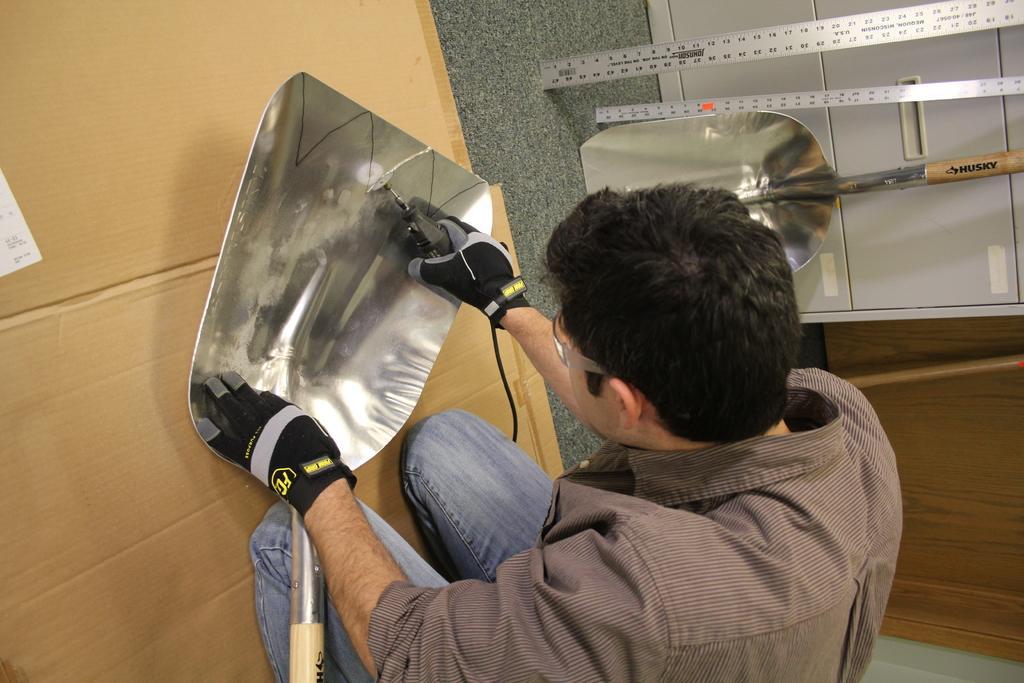Can you describe this image briefly? In this image at the bottom there is one man who is sitting and he is holding some instruments and doing something, and there is one box at the bottom. On the right side there are some cupboards, tables, scale and one spatula. 